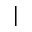<formula> <loc_0><loc_0><loc_500><loc_500>|</formula> 